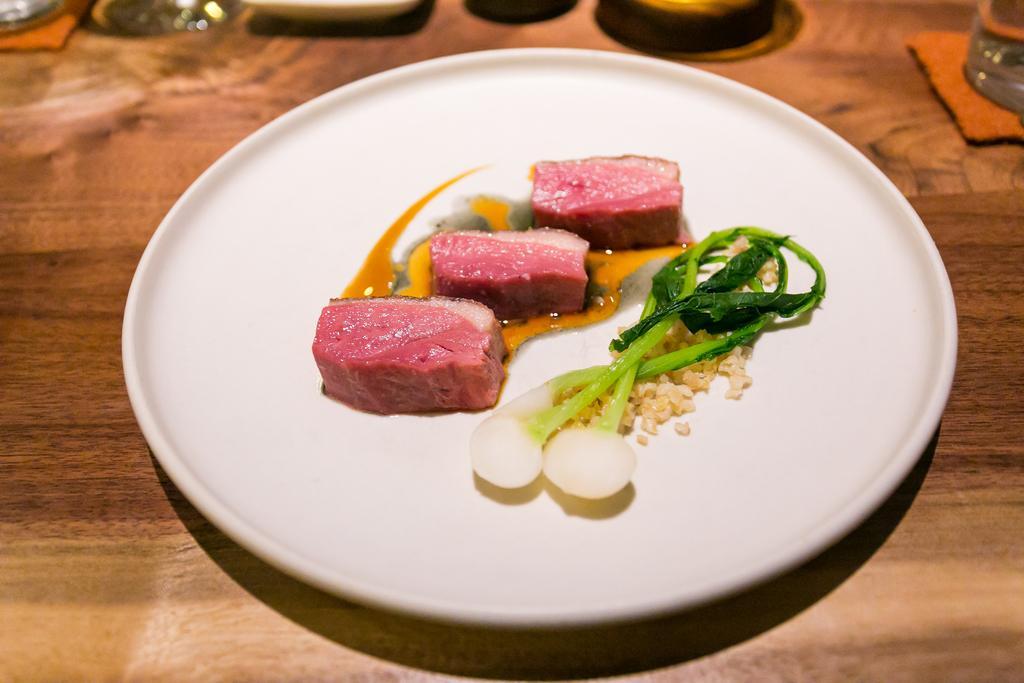Please provide a concise description of this image. In this image there is food on the plate, there is a plate on the surface, there are objects truncated, there is an object towards the right that is truncated. 